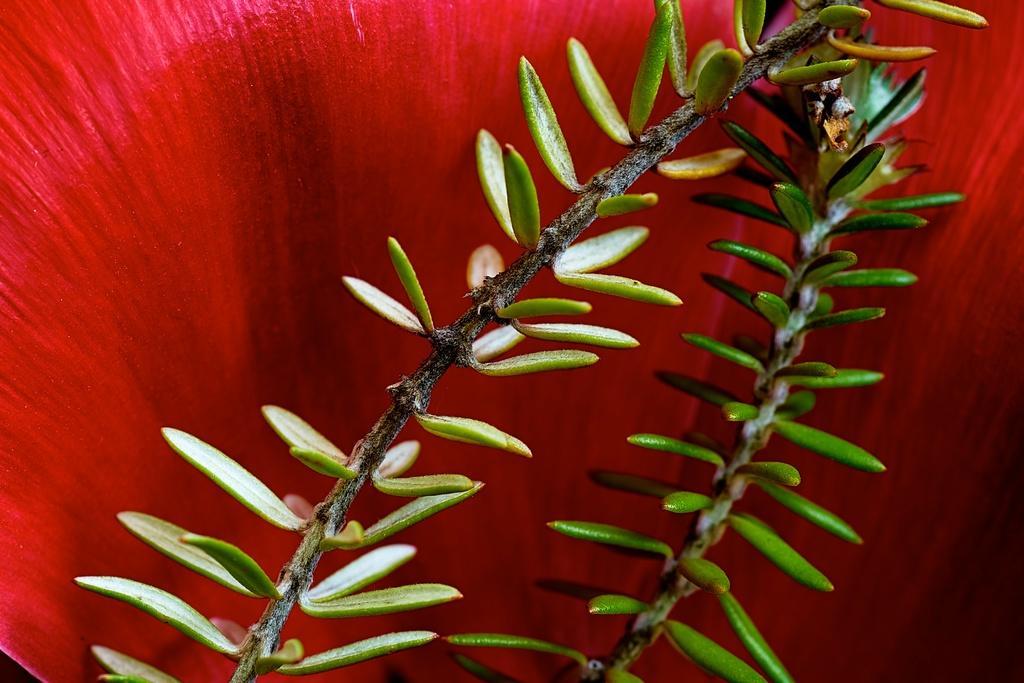What is the focus of the image? The image is zoomed in, so the focus is on a specific detail. What can be seen in the center of the image? There is a stem in the center of the image. What type of plant features are visible in the image? There are leaves in the image. What color can be seen in the background of the image? There is a red color object in the background of the image. What type of fuel is being used by the brass object in the image? There is no brass object or fuel present in the image. How does the crack in the stem affect the plant's growth in the image? There is no crack in the stem visible in the image. 